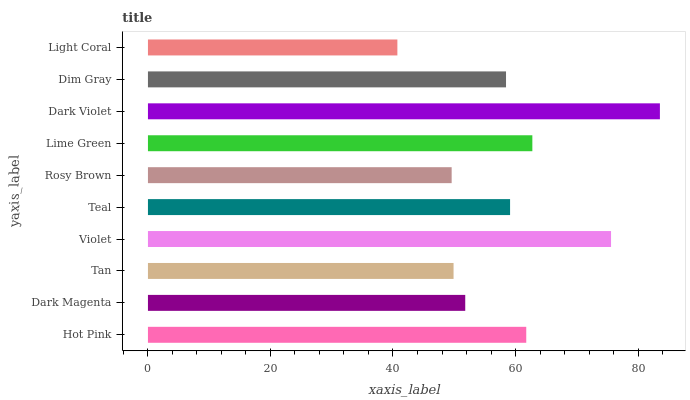Is Light Coral the minimum?
Answer yes or no. Yes. Is Dark Violet the maximum?
Answer yes or no. Yes. Is Dark Magenta the minimum?
Answer yes or no. No. Is Dark Magenta the maximum?
Answer yes or no. No. Is Hot Pink greater than Dark Magenta?
Answer yes or no. Yes. Is Dark Magenta less than Hot Pink?
Answer yes or no. Yes. Is Dark Magenta greater than Hot Pink?
Answer yes or no. No. Is Hot Pink less than Dark Magenta?
Answer yes or no. No. Is Teal the high median?
Answer yes or no. Yes. Is Dim Gray the low median?
Answer yes or no. Yes. Is Light Coral the high median?
Answer yes or no. No. Is Violet the low median?
Answer yes or no. No. 